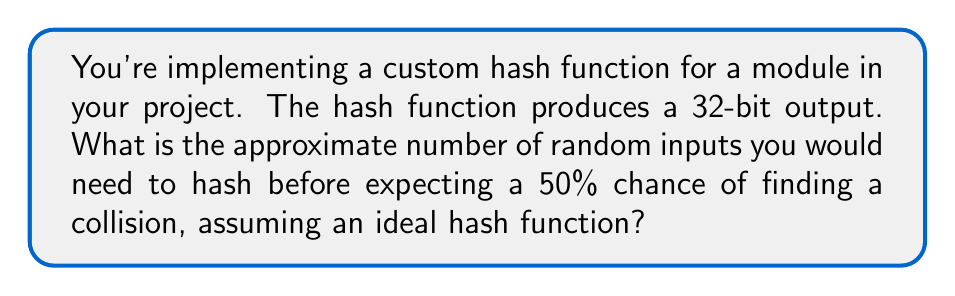Could you help me with this problem? Let's approach this step-by-step:

1) For a hash function with an n-bit output, there are $2^n$ possible hash values.

2) In this case, n = 32, so there are $2^{32}$ possible hash values.

3) This scenario is an instance of the "Birthday Problem" in probability theory. The number of inputs needed for a 50% chance of collision is approximately:

   $$\sqrt{2 \ln(2) \cdot 2^n}$$

4) Substituting n = 32:

   $$\sqrt{2 \ln(2) \cdot 2^{32}}$$

5) Simplifying:
   $$\sqrt{2 \ln(2) \cdot 4,294,967,296}$$
   $$\approx 77,163$$

6) Therefore, you would need to hash approximately 77,163 random inputs to have a 50% chance of finding a collision.

This relatively small number (compared to $2^{32}$) illustrates why 32-bit hash functions are not considered cryptographically secure for most applications in modern systems.
Answer: 77,163 